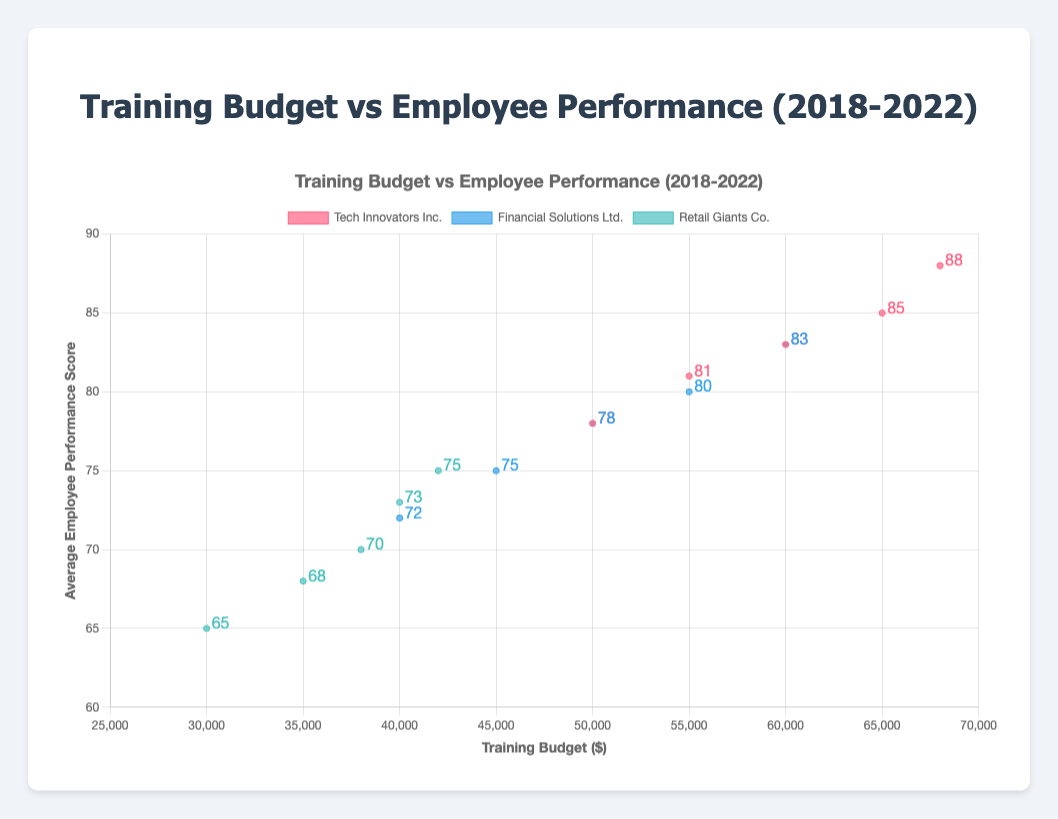What is the title of the graph? The title of the graph is displayed at the top and reads "Training Budget vs Employee Performance (2018-2022)"
Answer: Training Budget vs Employee Performance (2018-2022) What are the x and y axes labeled as? The x-axis is labeled "Training Budget ($)" while the y-axis is labeled "Average Employee Performance Score"
Answer: Training Budget ($) and Average Employee Performance Score Which company has the highest average employee performance score in 2022? By examining the data points, the highest average employee performance score in 2022 is 88, which belongs to "Tech Innovators Inc."
Answer: Tech Innovators Inc How does the training budget of "Retail Giants Co." in 2020 compare to its training budget in 2018? To find this, compare the training budgets of "Retail Giants Co." in respective years: 2018 = $30000 and 2020 = $38000. The budget increased by $8000.
Answer: Increased by $8000 What general trend do you observe in the relationship between training budget and employee performance score? Observing the scatter plot with a trend line, as the training budget increases, the average employee performance score also tends to increase.
Answer: Both increase Which company showed the most consistent year-over-year improvement in employee performance score? Observing the annual performance score progression for each company, "Tech Innovators Inc." consistently improved every year from 2018 to 2022
Answer: Tech Innovators Inc Compare the training budget of "Tech Innovators Inc." and "Financial Solutions Ltd." in 2019. Which company spent more and by how much? "Tech Innovators Inc." had a training budget of $55000 while "Financial Solutions Ltd." had $45000 in 2019. Tech Innovators Inc. spent $10000 more.
Answer: Tech Innovators Inc., $10000 more What was the average training budget of "Financial Solutions Ltd." over the five years presented? Sum the budgets (40000 + 45000 + 50000 + 55000 + 60000) and divide by the number of years (5): Total budget = $250000, Average budget = $250000 / 5 = $50000
Answer: $50000 Which company had the lowest performance score, and in which year? The lowest performance score displayed is 65, which belongs to "Retail Giants Co." in the year 2018.
Answer: Retail Giants Co., 2018 Given the trend lines, which company appears to benefit most from increased training budgets in terms of employee performance score? By assessing the slope of the trend lines, "Tech Innovators Inc." shows the most significant positive change in employee performance score relative to increased training budgets.
Answer: Tech Innovators Inc 